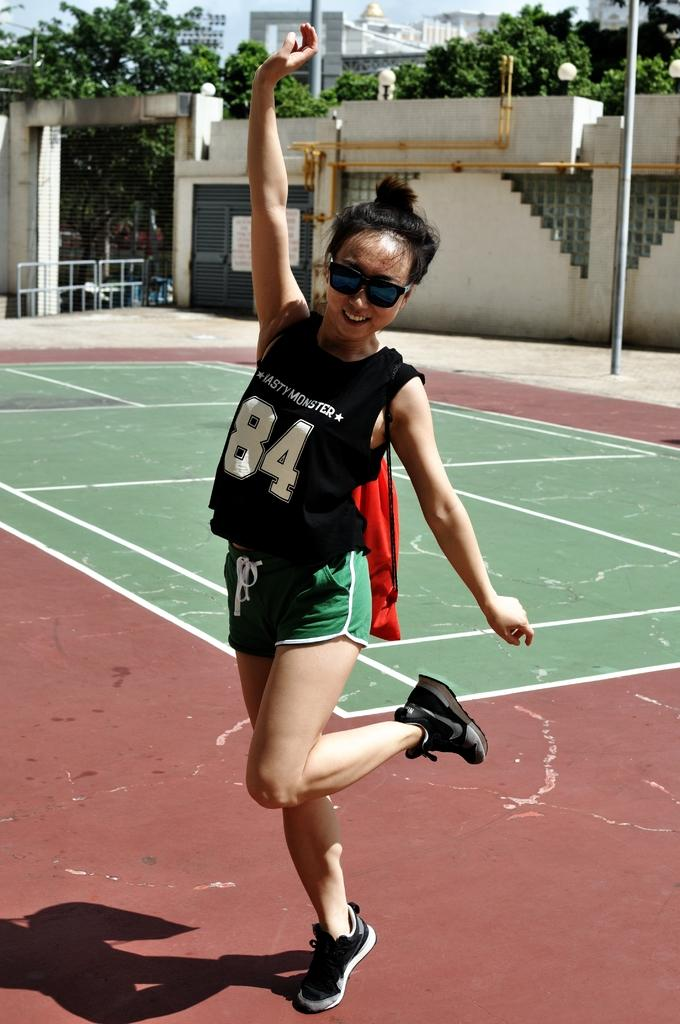<image>
Create a compact narrative representing the image presented. The girl is wearing number 84 on her shirt front. 